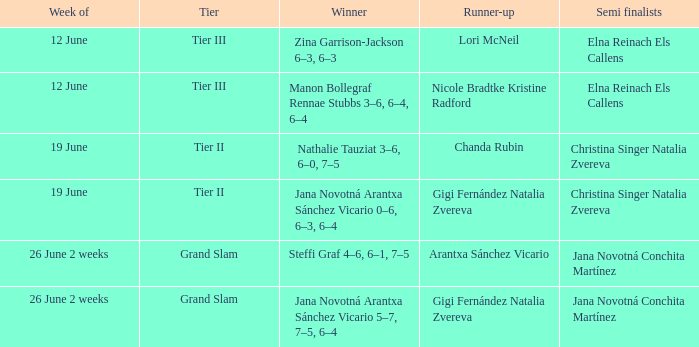Who is the champion in the week listed as 26 june 2 weeks, when the second-place finisher is arantxa sánchez vicario? Steffi Graf 4–6, 6–1, 7–5. 